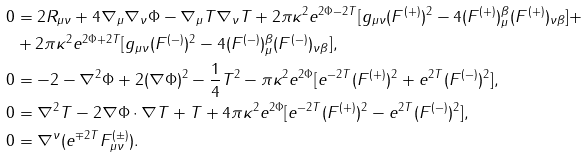<formula> <loc_0><loc_0><loc_500><loc_500>0 & = 2 R _ { \mu \nu } + 4 \nabla _ { \mu } \nabla _ { \nu } \Phi - \nabla _ { \mu } T \nabla _ { \nu } T + 2 \pi \kappa ^ { 2 } e ^ { 2 \Phi - 2 T } [ g _ { \mu \nu } ( F ^ { ( + ) } ) ^ { 2 } - 4 ( F ^ { ( + ) } ) _ { \mu } ^ { \beta } ( F ^ { ( + ) } ) _ { \nu \beta } ] + \\ & + 2 \pi \kappa ^ { 2 } e ^ { 2 \Phi + 2 T } [ g _ { \mu \nu } ( F ^ { ( - ) } ) ^ { 2 } - 4 ( F ^ { ( - ) } ) _ { \mu } ^ { \beta } ( F ^ { ( - ) } ) _ { \nu \beta } ] , \\ 0 & = - 2 - \nabla ^ { 2 } \Phi + 2 ( \nabla \Phi ) ^ { 2 } - \frac { 1 } { 4 } T ^ { 2 } - \pi \kappa ^ { 2 } e ^ { 2 \Phi } [ e ^ { - 2 T } ( F ^ { ( + ) } ) ^ { 2 } + e ^ { 2 T } ( F ^ { ( - ) } ) ^ { 2 } ] , \\ 0 & = \nabla ^ { 2 } T - 2 \nabla \Phi \cdot \nabla T + T + 4 \pi \kappa ^ { 2 } e ^ { 2 \Phi } [ e ^ { - 2 T } ( F ^ { ( + ) } ) ^ { 2 } - e ^ { 2 T } ( F ^ { ( - ) } ) ^ { 2 } ] , \\ 0 & = \nabla ^ { \nu } ( e ^ { \mp 2 T } F ^ { ( \pm ) } _ { \mu \nu } ) .</formula> 